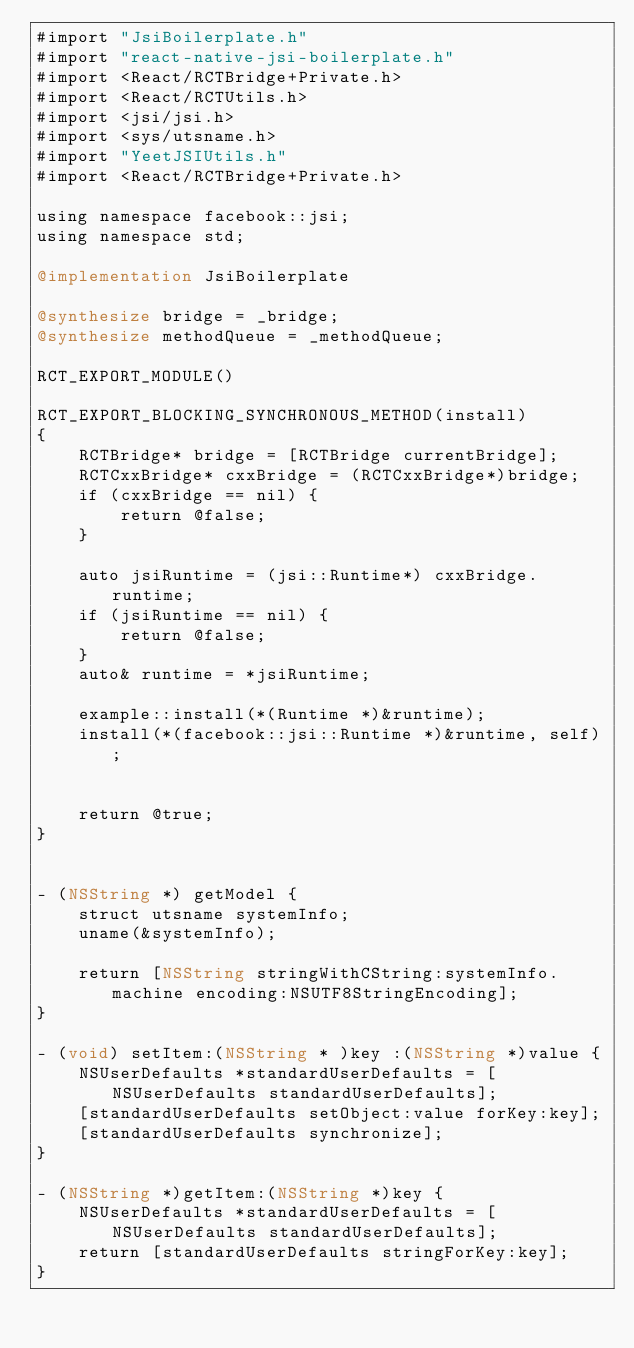Convert code to text. <code><loc_0><loc_0><loc_500><loc_500><_ObjectiveC_>#import "JsiBoilerplate.h"
#import "react-native-jsi-boilerplate.h"
#import <React/RCTBridge+Private.h>
#import <React/RCTUtils.h>
#import <jsi/jsi.h>
#import <sys/utsname.h>
#import "YeetJSIUtils.h"
#import <React/RCTBridge+Private.h>

using namespace facebook::jsi;
using namespace std;

@implementation JsiBoilerplate

@synthesize bridge = _bridge;
@synthesize methodQueue = _methodQueue;

RCT_EXPORT_MODULE()

RCT_EXPORT_BLOCKING_SYNCHRONOUS_METHOD(install)
{
    RCTBridge* bridge = [RCTBridge currentBridge];
    RCTCxxBridge* cxxBridge = (RCTCxxBridge*)bridge;
    if (cxxBridge == nil) {
        return @false;
    }

    auto jsiRuntime = (jsi::Runtime*) cxxBridge.runtime;
    if (jsiRuntime == nil) {
        return @false;
    }
    auto& runtime = *jsiRuntime;

    example::install(*(Runtime *)&runtime);
    install(*(facebook::jsi::Runtime *)&runtime, self);
  
   
    return @true;
}


- (NSString *) getModel {
    struct utsname systemInfo;
    uname(&systemInfo);
    
    return [NSString stringWithCString:systemInfo.machine encoding:NSUTF8StringEncoding];
}

- (void) setItem:(NSString * )key :(NSString *)value {
    NSUserDefaults *standardUserDefaults = [NSUserDefaults standardUserDefaults];
    [standardUserDefaults setObject:value forKey:key];
    [standardUserDefaults synchronize];
}

- (NSString *)getItem:(NSString *)key {
    NSUserDefaults *standardUserDefaults = [NSUserDefaults standardUserDefaults];
    return [standardUserDefaults stringForKey:key];
}
</code> 